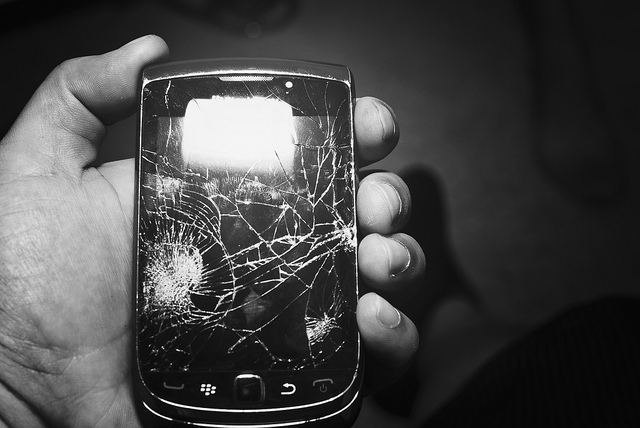Can you tell me more about the significance of the physical keyboard on this phone? Certainly! The physical keyboard, as seen on the Blackberry in the image, was highly valued for its tactile feedback and ease of typing compared to touch screens. It appealed particularly to business professionals who required efficient and accurate typing for emails and documents. Has the popularity of such keyboards declined over time? Yes, the popularity of physical keyboards has declined with the advent of advanced touch screen technologies, which offer larger display areas and versatile software configurations. Today, most smartphones feature touch-only inputs, aligning with consumer preferences for media consumption and sleek design. 